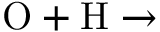Convert formula to latex. <formula><loc_0><loc_0><loc_500><loc_500>O + H \rightarrow</formula> 